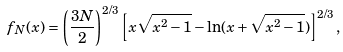<formula> <loc_0><loc_0><loc_500><loc_500>f _ { N } ( x ) = \left ( \frac { 3 N } { 2 } \right ) ^ { 2 / 3 } \left [ x \sqrt { x ^ { 2 } - 1 } - \ln ( x + \sqrt { x ^ { 2 } - 1 } ) \right ] ^ { 2 / 3 } ,</formula> 